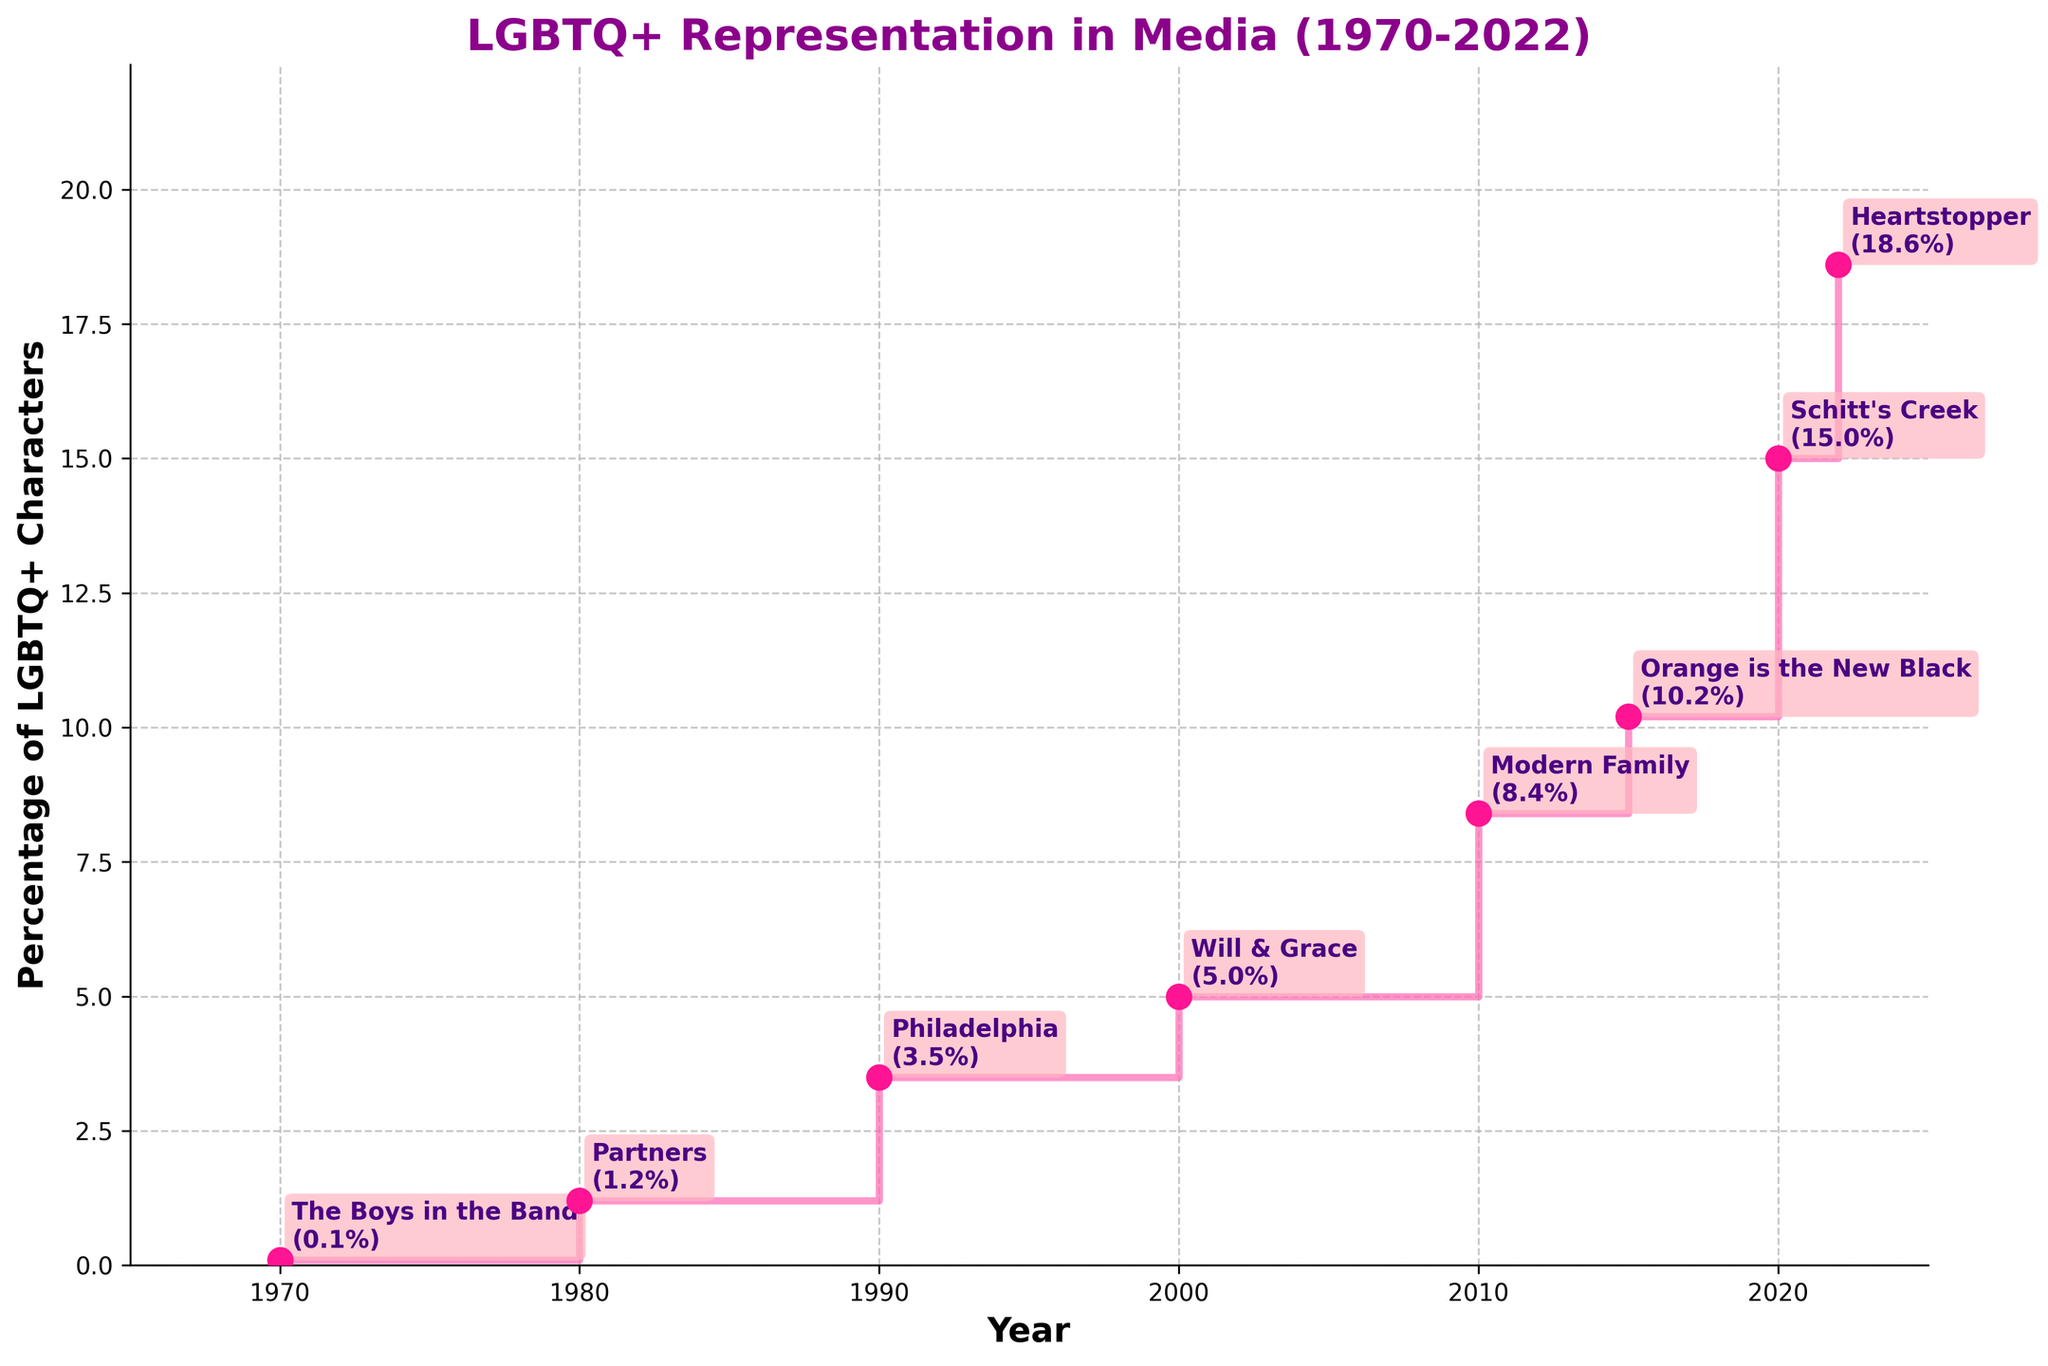What's the overall trend in LGBTQ+ representation in media from 1970 to 2022? The percentage of LGBTQ+ characters in media shows an increasing trend from 0.1% in 1970 to 18.6% in 2022, indicating a significant rise in representation over the years.
Answer: Increasing What is the highest percentage of LGBTQ+ characters depicted and in which year? The highest percentage depicted is 18.6% in the year 2022, as marked by 'Heartstopper'.
Answer: 18.6%, 2022 How does the representation of LGBTQ+ characters in 1990 compare to that in 2000? In 1990, the representation was 3.5%, while in 2000 it increased to 5.0%. Thus, there was a rise of 1.5% over the decade.
Answer: 1.5% increase Which decade saw the largest increase in the percentage of LGBTQ+ characters? By comparing the decades: 1970-1980 (1.1% increase), 1980-1990 (2.3% increase), 1990-2000 (1.5% increase), 2000-2010 (3.4% increase), 2010-2020 (6.6% increase), 2020-2022 (3.6% increase in just 2 years), the decade 2010-2020 saw the largest increase with a 6.6% rise.
Answer: 2010-2020 Identify the notable show or film for the year 2000. As labeled on the plot, the notable show or film for the year 2000 is 'Will & Grace'.
Answer: Will & Grace What is the percentage of LGBTQ+ characters shown by 'Modern Family' in 2010? The figure annotates 'Modern Family' in 2010, which depicted 8.4% LGBTQ+ characters.
Answer: 8.4% Calculate the average percentage increase per year from 2000 to 2020. The percentage in 2000 is 5.0% and in 2020 it is 15.0%. The increase is 10% over 20 years. Thus, the average annual increase is 10/20 = 0.5%.
Answer: 0.5% Were there any periods when the percentage of LGBTQ+ characters did not increase? The stair plot shows each step as a non-decreasing trend, meaning there were no periods when the percentage decreased.
Answer: No What is the difference in LGBTQ+ representation between 'Philadelphia' (1990) and 'Orange is the New Black' (2015)? 'Philadelphia' in 1990 showed 3.5%, and 'Orange is the New Black' in 2015 showed 10.2%. The difference is 10.2% - 3.5% = 6.7%.
Answer: 6.7% Name the shows/films and the corresponding years with at least 10% LGBTQ+ characters. The shows/films with at least 10% LGBTQ+ characters are 'Orange is the New Black' in 2015 (10.2%), 'Schitt's Creek' in 2020 (15.0%), and 'Heartstopper' in 2022 (18.6%).
Answer: Orange is the New Black, Schitt's Creek, Heartstopper 